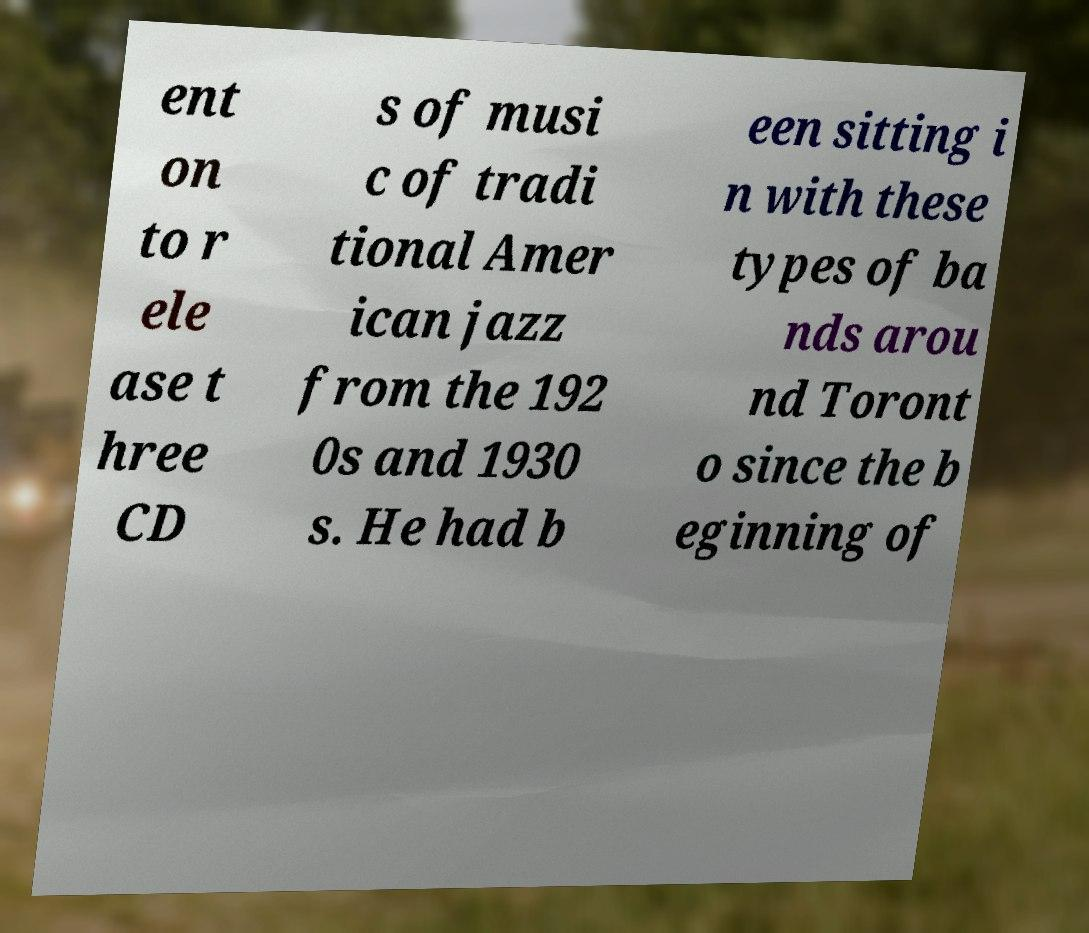I need the written content from this picture converted into text. Can you do that? ent on to r ele ase t hree CD s of musi c of tradi tional Amer ican jazz from the 192 0s and 1930 s. He had b een sitting i n with these types of ba nds arou nd Toront o since the b eginning of 